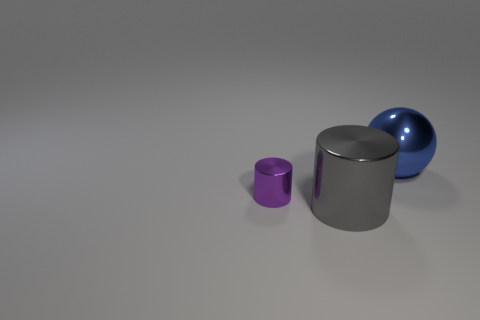There is another shiny object that is the same shape as the big gray thing; what is its color?
Keep it short and to the point. Purple. Is the color of the metallic cylinder that is in front of the small purple metal thing the same as the big metal sphere?
Your answer should be very brief. No. Does the gray cylinder have the same size as the purple object?
Make the answer very short. No. What shape is the other big thing that is made of the same material as the large gray thing?
Ensure brevity in your answer.  Sphere. What number of other objects are the same shape as the small object?
Your answer should be compact. 1. What shape is the big metal thing that is behind the big metal object that is on the left side of the metal thing behind the small purple metal cylinder?
Give a very brief answer. Sphere. What number of balls are either tiny cyan matte objects or big blue objects?
Provide a succinct answer. 1. There is a large metallic object in front of the large blue metallic ball; are there any things that are behind it?
Your answer should be very brief. Yes. There is a tiny thing; does it have the same shape as the object that is behind the tiny purple metallic cylinder?
Offer a terse response. No. What number of other things are the same size as the gray shiny object?
Make the answer very short. 1. 